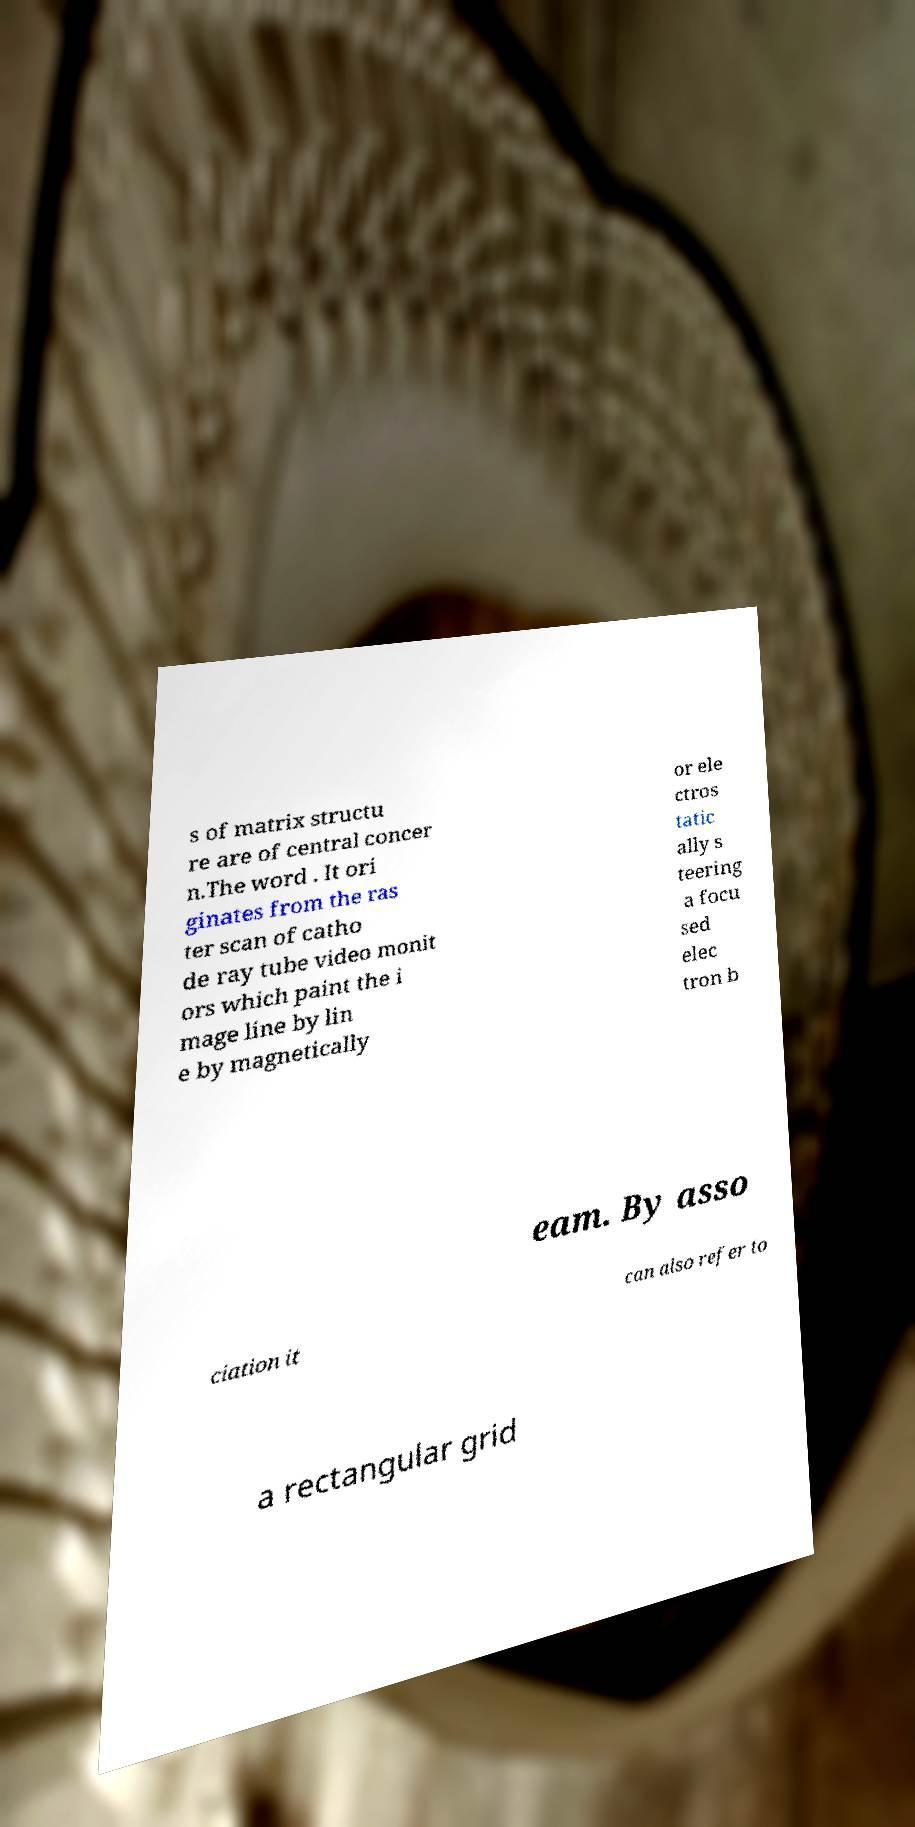What messages or text are displayed in this image? I need them in a readable, typed format. s of matrix structu re are of central concer n.The word . It ori ginates from the ras ter scan of catho de ray tube video monit ors which paint the i mage line by lin e by magnetically or ele ctros tatic ally s teering a focu sed elec tron b eam. By asso ciation it can also refer to a rectangular grid 